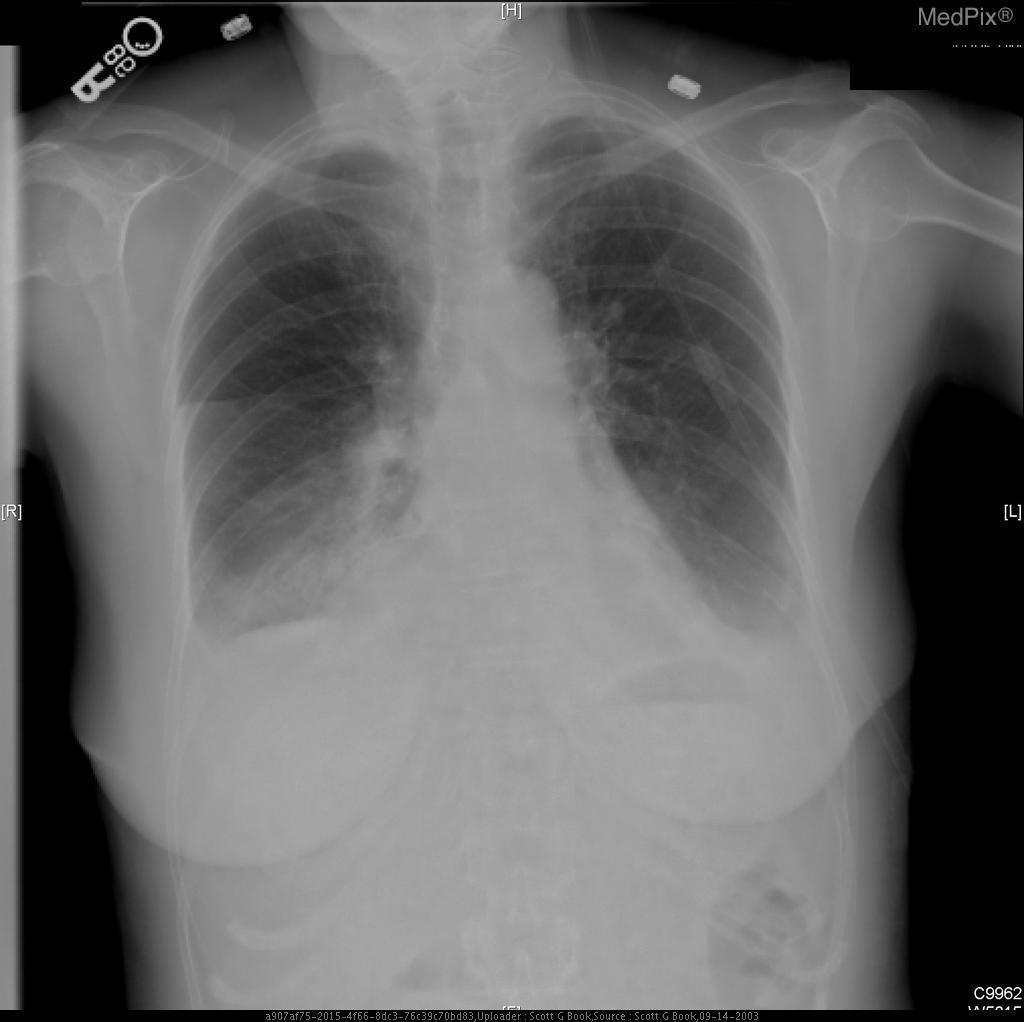What type of imaging is this?
Be succinct. Xray. What is the pathology seen above?
Give a very brief answer. Bilateral pleural effusion. What abnormality is seen in this image?
Answer briefly. Bilateral pleural effusion. Is there a pneumothorax seen in the above image?
Answer briefly. No. Is there a pneumothorax present?
Quick response, please. No. In which side is the hemidiaphragm elevated?
Short answer required. Right. Which diaphragm is elevated?
Short answer required. Right. 